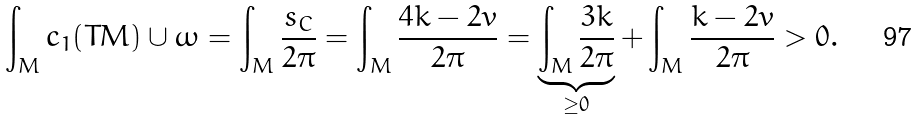<formula> <loc_0><loc_0><loc_500><loc_500>\int _ { M } c _ { 1 } ( T M ) \cup \omega = \int _ { M } \frac { s _ { C } } { 2 \pi } = \int _ { M } \frac { 4 k - 2 v } { 2 \pi } = \underbrace { \int _ { M } \frac { 3 k } { 2 \pi } } _ { \geq 0 } + \int _ { M } \frac { k - 2 v } { 2 \pi } > 0 .</formula> 